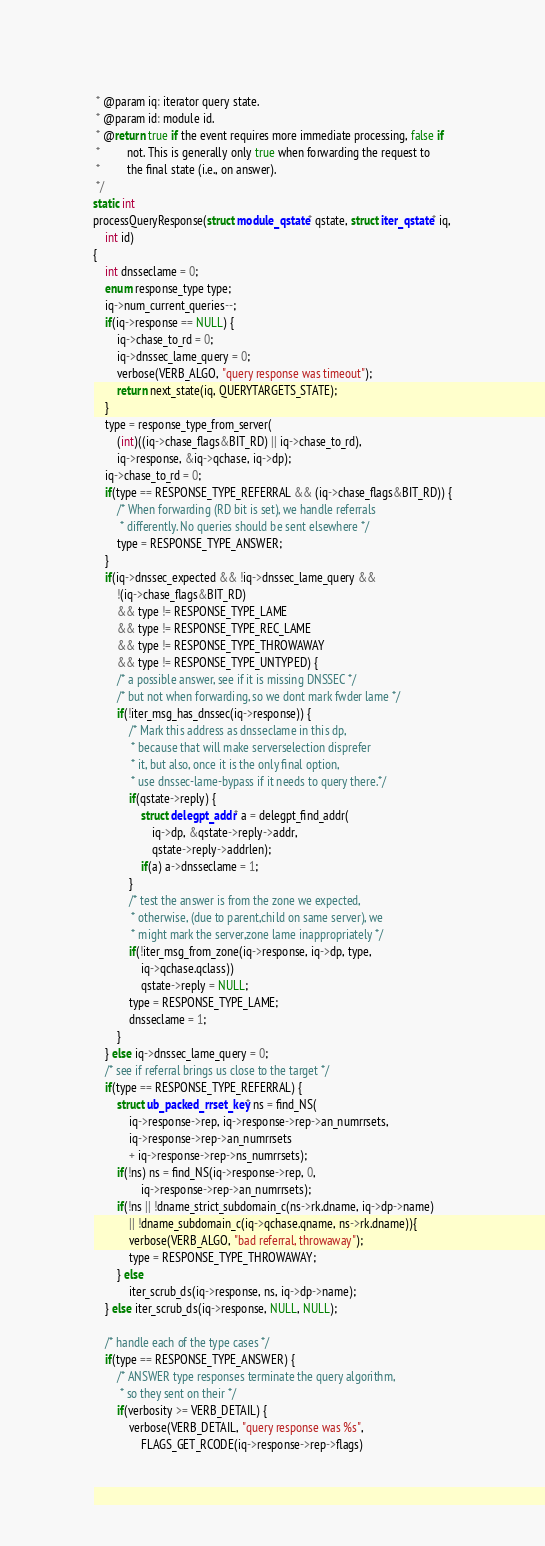<code> <loc_0><loc_0><loc_500><loc_500><_C_> * @param iq: iterator query state.
 * @param id: module id.
 * @return true if the event requires more immediate processing, false if
 *         not. This is generally only true when forwarding the request to
 *         the final state (i.e., on answer).
 */
static int
processQueryResponse(struct module_qstate* qstate, struct iter_qstate* iq,
	int id)
{
	int dnsseclame = 0;
	enum response_type type;
	iq->num_current_queries--;
	if(iq->response == NULL) {
		iq->chase_to_rd = 0;
		iq->dnssec_lame_query = 0;
		verbose(VERB_ALGO, "query response was timeout");
		return next_state(iq, QUERYTARGETS_STATE);
	}
	type = response_type_from_server(
		(int)((iq->chase_flags&BIT_RD) || iq->chase_to_rd),
		iq->response, &iq->qchase, iq->dp);
	iq->chase_to_rd = 0;
	if(type == RESPONSE_TYPE_REFERRAL && (iq->chase_flags&BIT_RD)) {
		/* When forwarding (RD bit is set), we handle referrals 
		 * differently. No queries should be sent elsewhere */
		type = RESPONSE_TYPE_ANSWER;
	}
	if(iq->dnssec_expected && !iq->dnssec_lame_query &&
		!(iq->chase_flags&BIT_RD) 
		&& type != RESPONSE_TYPE_LAME 
		&& type != RESPONSE_TYPE_REC_LAME 
		&& type != RESPONSE_TYPE_THROWAWAY 
		&& type != RESPONSE_TYPE_UNTYPED) {
		/* a possible answer, see if it is missing DNSSEC */
		/* but not when forwarding, so we dont mark fwder lame */
		if(!iter_msg_has_dnssec(iq->response)) {
			/* Mark this address as dnsseclame in this dp,
			 * because that will make serverselection disprefer
			 * it, but also, once it is the only final option,
			 * use dnssec-lame-bypass if it needs to query there.*/
			if(qstate->reply) {
				struct delegpt_addr* a = delegpt_find_addr(
					iq->dp, &qstate->reply->addr,
					qstate->reply->addrlen);
				if(a) a->dnsseclame = 1;
			}
			/* test the answer is from the zone we expected,
		 	 * otherwise, (due to parent,child on same server), we
		 	 * might mark the server,zone lame inappropriately */
			if(!iter_msg_from_zone(iq->response, iq->dp, type,
				iq->qchase.qclass))
				qstate->reply = NULL;
			type = RESPONSE_TYPE_LAME;
			dnsseclame = 1;
		}
	} else iq->dnssec_lame_query = 0;
	/* see if referral brings us close to the target */
	if(type == RESPONSE_TYPE_REFERRAL) {
		struct ub_packed_rrset_key* ns = find_NS(
			iq->response->rep, iq->response->rep->an_numrrsets,
			iq->response->rep->an_numrrsets 
			+ iq->response->rep->ns_numrrsets);
		if(!ns) ns = find_NS(iq->response->rep, 0, 
				iq->response->rep->an_numrrsets);
		if(!ns || !dname_strict_subdomain_c(ns->rk.dname, iq->dp->name) 
			|| !dname_subdomain_c(iq->qchase.qname, ns->rk.dname)){
			verbose(VERB_ALGO, "bad referral, throwaway");
			type = RESPONSE_TYPE_THROWAWAY;
		} else
			iter_scrub_ds(iq->response, ns, iq->dp->name);
	} else iter_scrub_ds(iq->response, NULL, NULL);

	/* handle each of the type cases */
	if(type == RESPONSE_TYPE_ANSWER) {
		/* ANSWER type responses terminate the query algorithm, 
		 * so they sent on their */
		if(verbosity >= VERB_DETAIL) {
			verbose(VERB_DETAIL, "query response was %s",
				FLAGS_GET_RCODE(iq->response->rep->flags)</code> 